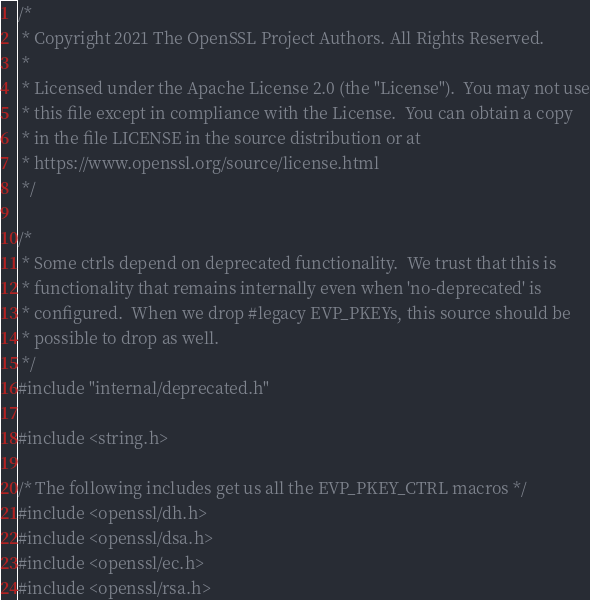<code> <loc_0><loc_0><loc_500><loc_500><_C_>/*
 * Copyright 2021 The OpenSSL Project Authors. All Rights Reserved.
 *
 * Licensed under the Apache License 2.0 (the "License").  You may not use
 * this file except in compliance with the License.  You can obtain a copy
 * in the file LICENSE in the source distribution or at
 * https://www.openssl.org/source/license.html
 */

/*
 * Some ctrls depend on deprecated functionality.  We trust that this is
 * functionality that remains internally even when 'no-deprecated' is
 * configured.  When we drop #legacy EVP_PKEYs, this source should be
 * possible to drop as well.
 */
#include "internal/deprecated.h"

#include <string.h>

/* The following includes get us all the EVP_PKEY_CTRL macros */
#include <openssl/dh.h>
#include <openssl/dsa.h>
#include <openssl/ec.h>
#include <openssl/rsa.h></code> 